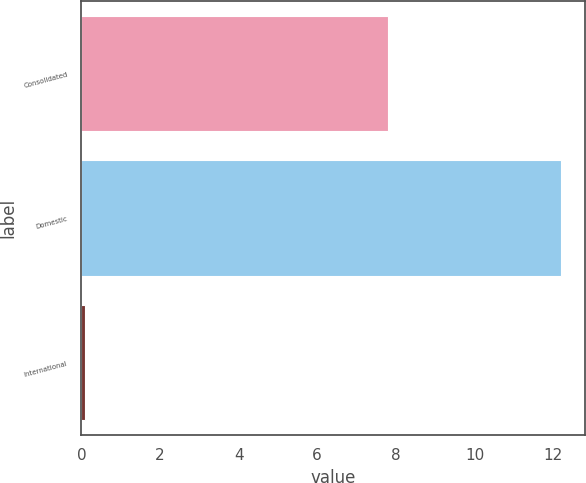Convert chart to OTSL. <chart><loc_0><loc_0><loc_500><loc_500><bar_chart><fcel>Consolidated<fcel>Domestic<fcel>International<nl><fcel>7.8<fcel>12.2<fcel>0.1<nl></chart> 